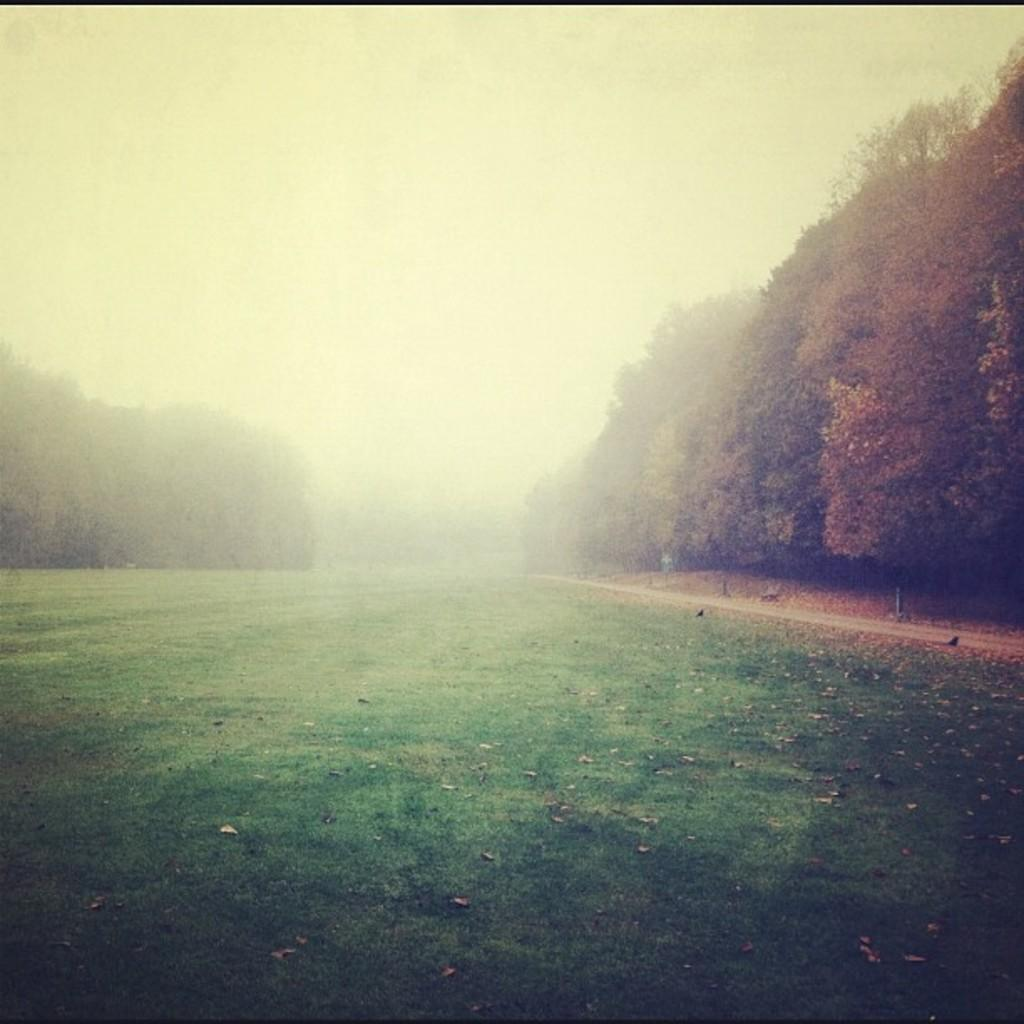What type of surface covers the ground in the image? The ground in the image is covered with grass. What other natural elements can be seen in the image? There are there any trees? What can be seen in the distance in the image? The sky is visible in the background of the image. How does the sock help the trees grow in the image? There is no sock present in the image, and therefore it cannot help the trees grow. 